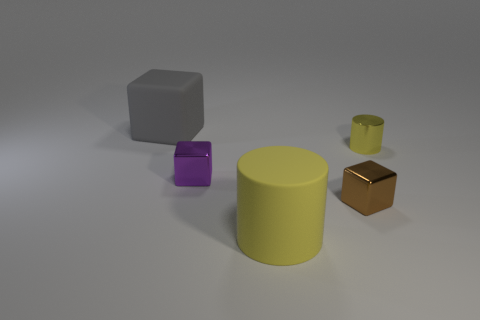How many things are either shiny balls or metal objects? 3 